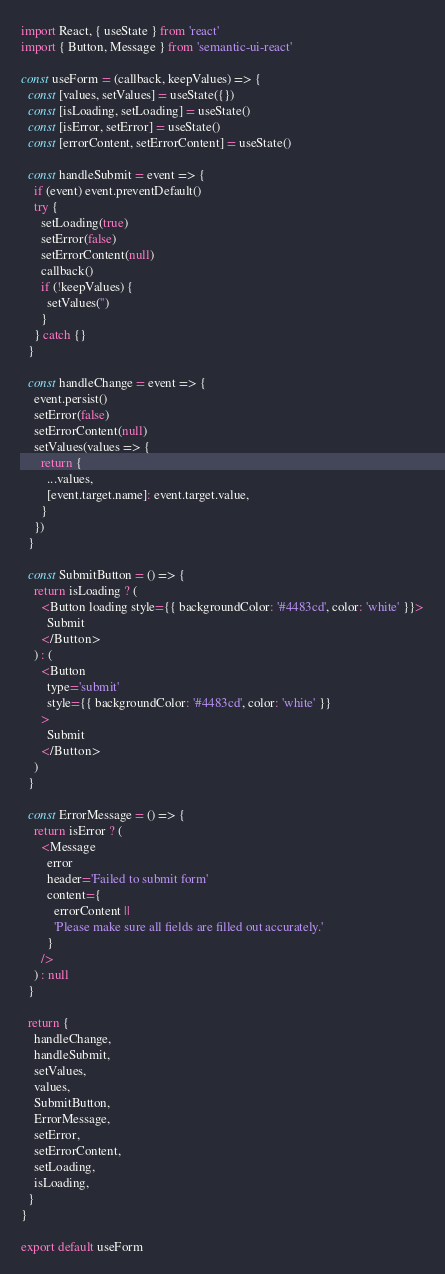Convert code to text. <code><loc_0><loc_0><loc_500><loc_500><_JavaScript_>import React, { useState } from 'react'
import { Button, Message } from 'semantic-ui-react'

const useForm = (callback, keepValues) => {
  const [values, setValues] = useState({})
  const [isLoading, setLoading] = useState()
  const [isError, setError] = useState()
  const [errorContent, setErrorContent] = useState()

  const handleSubmit = event => {
    if (event) event.preventDefault()
    try {
      setLoading(true)
      setError(false)
      setErrorContent(null)
      callback()
      if (!keepValues) {
        setValues('')
      }
    } catch {}
  }

  const handleChange = event => {
    event.persist()
    setError(false)
    setErrorContent(null)
    setValues(values => {
      return {
        ...values,
        [event.target.name]: event.target.value,
      }
    })
  }

  const SubmitButton = () => {
    return isLoading ? (
      <Button loading style={{ backgroundColor: '#4483cd', color: 'white' }}>
        Submit
      </Button>
    ) : (
      <Button
        type='submit'
        style={{ backgroundColor: '#4483cd', color: 'white' }}
      >
        Submit
      </Button>
    )
  }

  const ErrorMessage = () => {
    return isError ? (
      <Message
        error
        header='Failed to submit form'
        content={
          errorContent ||
          'Please make sure all fields are filled out accurately.'
        }
      />
    ) : null
  }

  return {
    handleChange,
    handleSubmit,
    setValues,
    values,
    SubmitButton,
    ErrorMessage,
    setError,
    setErrorContent,
    setLoading,
    isLoading,
  }
}

export default useForm
</code> 